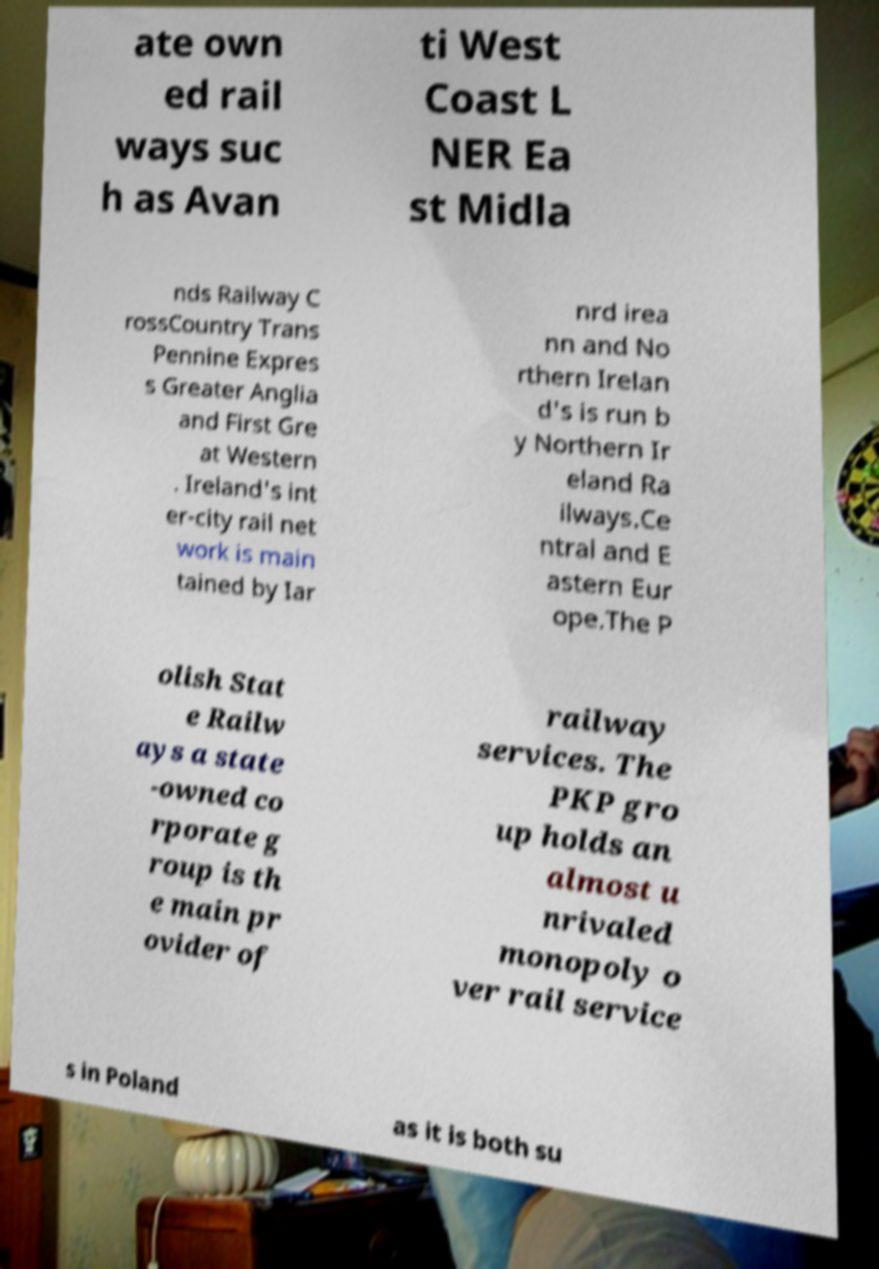Could you extract and type out the text from this image? ate own ed rail ways suc h as Avan ti West Coast L NER Ea st Midla nds Railway C rossCountry Trans Pennine Expres s Greater Anglia and First Gre at Western . Ireland's int er-city rail net work is main tained by Iar nrd irea nn and No rthern Irelan d's is run b y Northern Ir eland Ra ilways.Ce ntral and E astern Eur ope.The P olish Stat e Railw ays a state -owned co rporate g roup is th e main pr ovider of railway services. The PKP gro up holds an almost u nrivaled monopoly o ver rail service s in Poland as it is both su 